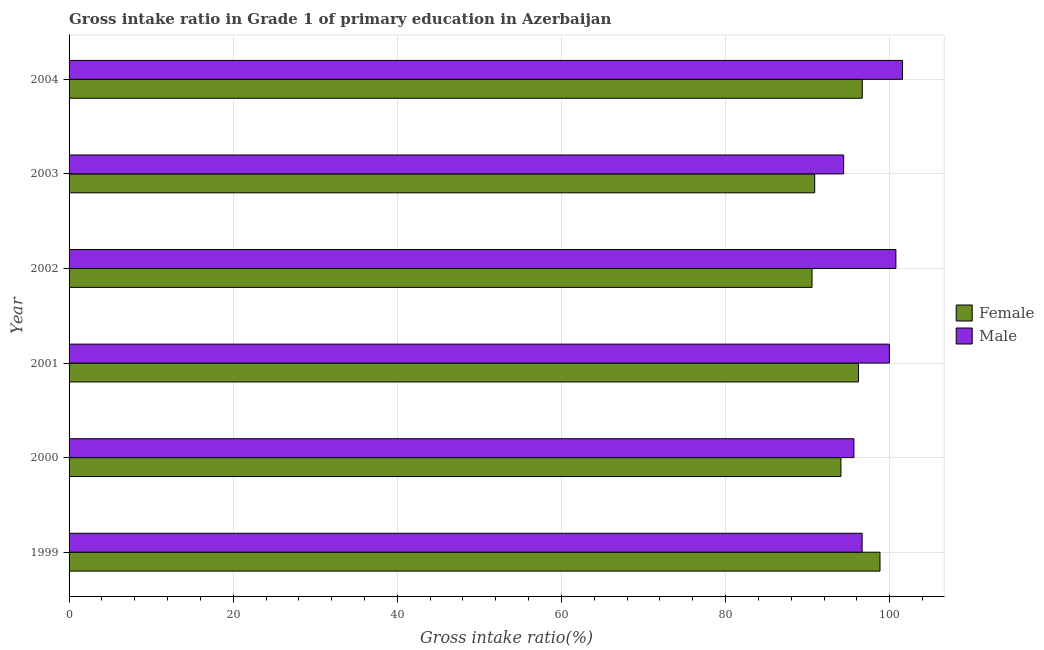How many different coloured bars are there?
Your answer should be compact. 2. Are the number of bars on each tick of the Y-axis equal?
Offer a very short reply. Yes. How many bars are there on the 4th tick from the top?
Offer a terse response. 2. What is the label of the 4th group of bars from the top?
Your answer should be compact. 2001. What is the gross intake ratio(female) in 1999?
Provide a short and direct response. 98.82. Across all years, what is the maximum gross intake ratio(female)?
Provide a short and direct response. 98.82. Across all years, what is the minimum gross intake ratio(female)?
Ensure brevity in your answer.  90.53. In which year was the gross intake ratio(female) minimum?
Ensure brevity in your answer.  2002. What is the total gross intake ratio(female) in the graph?
Give a very brief answer. 567.11. What is the difference between the gross intake ratio(female) in 2000 and that in 2003?
Give a very brief answer. 3.19. What is the difference between the gross intake ratio(female) in 1999 and the gross intake ratio(male) in 2004?
Give a very brief answer. -2.74. What is the average gross intake ratio(male) per year?
Provide a short and direct response. 98.16. In the year 2004, what is the difference between the gross intake ratio(male) and gross intake ratio(female)?
Keep it short and to the point. 4.91. In how many years, is the gross intake ratio(female) greater than 84 %?
Make the answer very short. 6. What is the ratio of the gross intake ratio(male) in 1999 to that in 2003?
Offer a terse response. 1.02. Is the difference between the gross intake ratio(female) in 1999 and 2004 greater than the difference between the gross intake ratio(male) in 1999 and 2004?
Your answer should be very brief. Yes. What is the difference between the highest and the second highest gross intake ratio(male)?
Ensure brevity in your answer.  0.81. What is the difference between the highest and the lowest gross intake ratio(male)?
Ensure brevity in your answer.  7.17. How many bars are there?
Provide a short and direct response. 12. How many years are there in the graph?
Your answer should be compact. 6. Does the graph contain any zero values?
Offer a terse response. No. Does the graph contain grids?
Keep it short and to the point. Yes. How many legend labels are there?
Make the answer very short. 2. How are the legend labels stacked?
Provide a short and direct response. Vertical. What is the title of the graph?
Provide a succinct answer. Gross intake ratio in Grade 1 of primary education in Azerbaijan. Does "Goods" appear as one of the legend labels in the graph?
Offer a very short reply. No. What is the label or title of the X-axis?
Keep it short and to the point. Gross intake ratio(%). What is the Gross intake ratio(%) of Female in 1999?
Provide a short and direct response. 98.82. What is the Gross intake ratio(%) in Male in 1999?
Keep it short and to the point. 96.64. What is the Gross intake ratio(%) of Female in 2000?
Offer a terse response. 94.05. What is the Gross intake ratio(%) of Male in 2000?
Ensure brevity in your answer.  95.64. What is the Gross intake ratio(%) in Female in 2001?
Your response must be concise. 96.19. What is the Gross intake ratio(%) in Male in 2001?
Ensure brevity in your answer.  99.96. What is the Gross intake ratio(%) of Female in 2002?
Your answer should be compact. 90.53. What is the Gross intake ratio(%) of Male in 2002?
Give a very brief answer. 100.76. What is the Gross intake ratio(%) of Female in 2003?
Make the answer very short. 90.86. What is the Gross intake ratio(%) in Male in 2003?
Your answer should be compact. 94.39. What is the Gross intake ratio(%) of Female in 2004?
Your answer should be compact. 96.66. What is the Gross intake ratio(%) in Male in 2004?
Offer a very short reply. 101.56. Across all years, what is the maximum Gross intake ratio(%) in Female?
Your response must be concise. 98.82. Across all years, what is the maximum Gross intake ratio(%) in Male?
Your response must be concise. 101.56. Across all years, what is the minimum Gross intake ratio(%) of Female?
Give a very brief answer. 90.53. Across all years, what is the minimum Gross intake ratio(%) in Male?
Make the answer very short. 94.39. What is the total Gross intake ratio(%) in Female in the graph?
Offer a very short reply. 567.11. What is the total Gross intake ratio(%) of Male in the graph?
Your answer should be very brief. 588.95. What is the difference between the Gross intake ratio(%) of Female in 1999 and that in 2000?
Give a very brief answer. 4.76. What is the difference between the Gross intake ratio(%) of Female in 1999 and that in 2001?
Your answer should be very brief. 2.62. What is the difference between the Gross intake ratio(%) in Male in 1999 and that in 2001?
Your response must be concise. -3.32. What is the difference between the Gross intake ratio(%) in Female in 1999 and that in 2002?
Ensure brevity in your answer.  8.28. What is the difference between the Gross intake ratio(%) in Male in 1999 and that in 2002?
Provide a short and direct response. -4.12. What is the difference between the Gross intake ratio(%) of Female in 1999 and that in 2003?
Provide a short and direct response. 7.96. What is the difference between the Gross intake ratio(%) of Male in 1999 and that in 2003?
Provide a succinct answer. 2.25. What is the difference between the Gross intake ratio(%) in Female in 1999 and that in 2004?
Keep it short and to the point. 2.16. What is the difference between the Gross intake ratio(%) of Male in 1999 and that in 2004?
Your response must be concise. -4.92. What is the difference between the Gross intake ratio(%) in Female in 2000 and that in 2001?
Offer a terse response. -2.14. What is the difference between the Gross intake ratio(%) in Male in 2000 and that in 2001?
Your answer should be very brief. -4.33. What is the difference between the Gross intake ratio(%) of Female in 2000 and that in 2002?
Your answer should be compact. 3.52. What is the difference between the Gross intake ratio(%) in Male in 2000 and that in 2002?
Your response must be concise. -5.12. What is the difference between the Gross intake ratio(%) of Female in 2000 and that in 2003?
Make the answer very short. 3.19. What is the difference between the Gross intake ratio(%) of Male in 2000 and that in 2003?
Ensure brevity in your answer.  1.25. What is the difference between the Gross intake ratio(%) of Female in 2000 and that in 2004?
Offer a very short reply. -2.6. What is the difference between the Gross intake ratio(%) in Male in 2000 and that in 2004?
Make the answer very short. -5.92. What is the difference between the Gross intake ratio(%) in Female in 2001 and that in 2002?
Ensure brevity in your answer.  5.66. What is the difference between the Gross intake ratio(%) in Male in 2001 and that in 2002?
Make the answer very short. -0.79. What is the difference between the Gross intake ratio(%) of Female in 2001 and that in 2003?
Offer a very short reply. 5.33. What is the difference between the Gross intake ratio(%) in Male in 2001 and that in 2003?
Your answer should be very brief. 5.58. What is the difference between the Gross intake ratio(%) in Female in 2001 and that in 2004?
Your response must be concise. -0.46. What is the difference between the Gross intake ratio(%) of Male in 2001 and that in 2004?
Give a very brief answer. -1.6. What is the difference between the Gross intake ratio(%) in Female in 2002 and that in 2003?
Provide a succinct answer. -0.33. What is the difference between the Gross intake ratio(%) in Male in 2002 and that in 2003?
Offer a terse response. 6.37. What is the difference between the Gross intake ratio(%) of Female in 2002 and that in 2004?
Give a very brief answer. -6.12. What is the difference between the Gross intake ratio(%) of Male in 2002 and that in 2004?
Make the answer very short. -0.81. What is the difference between the Gross intake ratio(%) of Female in 2003 and that in 2004?
Your response must be concise. -5.8. What is the difference between the Gross intake ratio(%) of Male in 2003 and that in 2004?
Your answer should be compact. -7.17. What is the difference between the Gross intake ratio(%) in Female in 1999 and the Gross intake ratio(%) in Male in 2000?
Your answer should be very brief. 3.18. What is the difference between the Gross intake ratio(%) of Female in 1999 and the Gross intake ratio(%) of Male in 2001?
Provide a succinct answer. -1.15. What is the difference between the Gross intake ratio(%) of Female in 1999 and the Gross intake ratio(%) of Male in 2002?
Provide a succinct answer. -1.94. What is the difference between the Gross intake ratio(%) in Female in 1999 and the Gross intake ratio(%) in Male in 2003?
Keep it short and to the point. 4.43. What is the difference between the Gross intake ratio(%) of Female in 1999 and the Gross intake ratio(%) of Male in 2004?
Keep it short and to the point. -2.74. What is the difference between the Gross intake ratio(%) in Female in 2000 and the Gross intake ratio(%) in Male in 2001?
Ensure brevity in your answer.  -5.91. What is the difference between the Gross intake ratio(%) in Female in 2000 and the Gross intake ratio(%) in Male in 2002?
Make the answer very short. -6.7. What is the difference between the Gross intake ratio(%) of Female in 2000 and the Gross intake ratio(%) of Male in 2003?
Make the answer very short. -0.33. What is the difference between the Gross intake ratio(%) of Female in 2000 and the Gross intake ratio(%) of Male in 2004?
Offer a terse response. -7.51. What is the difference between the Gross intake ratio(%) in Female in 2001 and the Gross intake ratio(%) in Male in 2002?
Ensure brevity in your answer.  -4.56. What is the difference between the Gross intake ratio(%) of Female in 2001 and the Gross intake ratio(%) of Male in 2003?
Offer a very short reply. 1.81. What is the difference between the Gross intake ratio(%) of Female in 2001 and the Gross intake ratio(%) of Male in 2004?
Your answer should be compact. -5.37. What is the difference between the Gross intake ratio(%) in Female in 2002 and the Gross intake ratio(%) in Male in 2003?
Ensure brevity in your answer.  -3.85. What is the difference between the Gross intake ratio(%) of Female in 2002 and the Gross intake ratio(%) of Male in 2004?
Give a very brief answer. -11.03. What is the difference between the Gross intake ratio(%) of Female in 2003 and the Gross intake ratio(%) of Male in 2004?
Ensure brevity in your answer.  -10.7. What is the average Gross intake ratio(%) in Female per year?
Ensure brevity in your answer.  94.52. What is the average Gross intake ratio(%) of Male per year?
Make the answer very short. 98.16. In the year 1999, what is the difference between the Gross intake ratio(%) in Female and Gross intake ratio(%) in Male?
Offer a very short reply. 2.18. In the year 2000, what is the difference between the Gross intake ratio(%) of Female and Gross intake ratio(%) of Male?
Ensure brevity in your answer.  -1.58. In the year 2001, what is the difference between the Gross intake ratio(%) of Female and Gross intake ratio(%) of Male?
Offer a terse response. -3.77. In the year 2002, what is the difference between the Gross intake ratio(%) of Female and Gross intake ratio(%) of Male?
Offer a very short reply. -10.22. In the year 2003, what is the difference between the Gross intake ratio(%) in Female and Gross intake ratio(%) in Male?
Provide a short and direct response. -3.53. In the year 2004, what is the difference between the Gross intake ratio(%) in Female and Gross intake ratio(%) in Male?
Your response must be concise. -4.91. What is the ratio of the Gross intake ratio(%) in Female in 1999 to that in 2000?
Make the answer very short. 1.05. What is the ratio of the Gross intake ratio(%) in Male in 1999 to that in 2000?
Offer a terse response. 1.01. What is the ratio of the Gross intake ratio(%) of Female in 1999 to that in 2001?
Provide a succinct answer. 1.03. What is the ratio of the Gross intake ratio(%) in Male in 1999 to that in 2001?
Ensure brevity in your answer.  0.97. What is the ratio of the Gross intake ratio(%) of Female in 1999 to that in 2002?
Give a very brief answer. 1.09. What is the ratio of the Gross intake ratio(%) of Male in 1999 to that in 2002?
Your response must be concise. 0.96. What is the ratio of the Gross intake ratio(%) of Female in 1999 to that in 2003?
Ensure brevity in your answer.  1.09. What is the ratio of the Gross intake ratio(%) of Male in 1999 to that in 2003?
Make the answer very short. 1.02. What is the ratio of the Gross intake ratio(%) in Female in 1999 to that in 2004?
Ensure brevity in your answer.  1.02. What is the ratio of the Gross intake ratio(%) of Male in 1999 to that in 2004?
Offer a terse response. 0.95. What is the ratio of the Gross intake ratio(%) in Female in 2000 to that in 2001?
Provide a short and direct response. 0.98. What is the ratio of the Gross intake ratio(%) in Male in 2000 to that in 2001?
Offer a terse response. 0.96. What is the ratio of the Gross intake ratio(%) in Female in 2000 to that in 2002?
Your response must be concise. 1.04. What is the ratio of the Gross intake ratio(%) in Male in 2000 to that in 2002?
Your response must be concise. 0.95. What is the ratio of the Gross intake ratio(%) of Female in 2000 to that in 2003?
Your response must be concise. 1.04. What is the ratio of the Gross intake ratio(%) in Male in 2000 to that in 2003?
Give a very brief answer. 1.01. What is the ratio of the Gross intake ratio(%) of Female in 2000 to that in 2004?
Your response must be concise. 0.97. What is the ratio of the Gross intake ratio(%) of Male in 2000 to that in 2004?
Give a very brief answer. 0.94. What is the ratio of the Gross intake ratio(%) of Female in 2001 to that in 2003?
Your answer should be compact. 1.06. What is the ratio of the Gross intake ratio(%) of Male in 2001 to that in 2003?
Offer a terse response. 1.06. What is the ratio of the Gross intake ratio(%) in Female in 2001 to that in 2004?
Ensure brevity in your answer.  1. What is the ratio of the Gross intake ratio(%) in Male in 2001 to that in 2004?
Your answer should be very brief. 0.98. What is the ratio of the Gross intake ratio(%) of Male in 2002 to that in 2003?
Your answer should be compact. 1.07. What is the ratio of the Gross intake ratio(%) of Female in 2002 to that in 2004?
Your answer should be very brief. 0.94. What is the ratio of the Gross intake ratio(%) in Male in 2003 to that in 2004?
Give a very brief answer. 0.93. What is the difference between the highest and the second highest Gross intake ratio(%) of Female?
Offer a very short reply. 2.16. What is the difference between the highest and the second highest Gross intake ratio(%) in Male?
Keep it short and to the point. 0.81. What is the difference between the highest and the lowest Gross intake ratio(%) of Female?
Provide a succinct answer. 8.28. What is the difference between the highest and the lowest Gross intake ratio(%) in Male?
Your answer should be very brief. 7.17. 